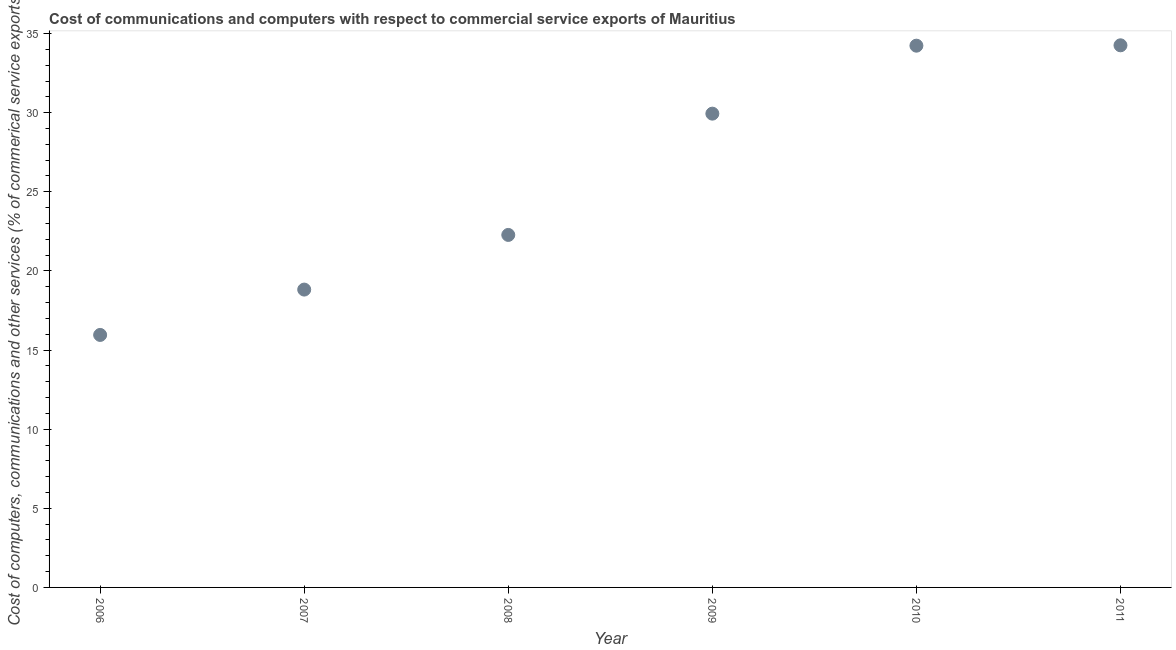What is the  computer and other services in 2011?
Offer a very short reply. 34.26. Across all years, what is the maximum  computer and other services?
Provide a short and direct response. 34.26. Across all years, what is the minimum  computer and other services?
Give a very brief answer. 15.96. In which year was the  computer and other services minimum?
Ensure brevity in your answer.  2006. What is the sum of the  computer and other services?
Your answer should be very brief. 155.49. What is the difference between the  computer and other services in 2008 and 2010?
Your answer should be very brief. -11.96. What is the average  computer and other services per year?
Your response must be concise. 25.91. What is the median  computer and other services?
Provide a short and direct response. 26.11. In how many years, is the cost of communications greater than 28 %?
Make the answer very short. 3. Do a majority of the years between 2009 and 2010 (inclusive) have  computer and other services greater than 10 %?
Your answer should be compact. Yes. What is the ratio of the  computer and other services in 2008 to that in 2010?
Provide a succinct answer. 0.65. What is the difference between the highest and the second highest  computer and other services?
Provide a short and direct response. 0.02. What is the difference between the highest and the lowest cost of communications?
Offer a terse response. 18.3. What is the difference between two consecutive major ticks on the Y-axis?
Give a very brief answer. 5. Are the values on the major ticks of Y-axis written in scientific E-notation?
Keep it short and to the point. No. Does the graph contain grids?
Your answer should be very brief. No. What is the title of the graph?
Make the answer very short. Cost of communications and computers with respect to commercial service exports of Mauritius. What is the label or title of the X-axis?
Provide a succinct answer. Year. What is the label or title of the Y-axis?
Ensure brevity in your answer.  Cost of computers, communications and other services (% of commerical service exports). What is the Cost of computers, communications and other services (% of commerical service exports) in 2006?
Offer a very short reply. 15.96. What is the Cost of computers, communications and other services (% of commerical service exports) in 2007?
Your response must be concise. 18.82. What is the Cost of computers, communications and other services (% of commerical service exports) in 2008?
Ensure brevity in your answer.  22.28. What is the Cost of computers, communications and other services (% of commerical service exports) in 2009?
Give a very brief answer. 29.94. What is the Cost of computers, communications and other services (% of commerical service exports) in 2010?
Provide a short and direct response. 34.24. What is the Cost of computers, communications and other services (% of commerical service exports) in 2011?
Provide a succinct answer. 34.26. What is the difference between the Cost of computers, communications and other services (% of commerical service exports) in 2006 and 2007?
Keep it short and to the point. -2.87. What is the difference between the Cost of computers, communications and other services (% of commerical service exports) in 2006 and 2008?
Your answer should be compact. -6.32. What is the difference between the Cost of computers, communications and other services (% of commerical service exports) in 2006 and 2009?
Offer a terse response. -13.98. What is the difference between the Cost of computers, communications and other services (% of commerical service exports) in 2006 and 2010?
Give a very brief answer. -18.28. What is the difference between the Cost of computers, communications and other services (% of commerical service exports) in 2006 and 2011?
Offer a very short reply. -18.3. What is the difference between the Cost of computers, communications and other services (% of commerical service exports) in 2007 and 2008?
Offer a terse response. -3.45. What is the difference between the Cost of computers, communications and other services (% of commerical service exports) in 2007 and 2009?
Your answer should be compact. -11.12. What is the difference between the Cost of computers, communications and other services (% of commerical service exports) in 2007 and 2010?
Make the answer very short. -15.41. What is the difference between the Cost of computers, communications and other services (% of commerical service exports) in 2007 and 2011?
Keep it short and to the point. -15.44. What is the difference between the Cost of computers, communications and other services (% of commerical service exports) in 2008 and 2009?
Your answer should be compact. -7.66. What is the difference between the Cost of computers, communications and other services (% of commerical service exports) in 2008 and 2010?
Your answer should be compact. -11.96. What is the difference between the Cost of computers, communications and other services (% of commerical service exports) in 2008 and 2011?
Provide a short and direct response. -11.98. What is the difference between the Cost of computers, communications and other services (% of commerical service exports) in 2009 and 2010?
Provide a succinct answer. -4.3. What is the difference between the Cost of computers, communications and other services (% of commerical service exports) in 2009 and 2011?
Give a very brief answer. -4.32. What is the difference between the Cost of computers, communications and other services (% of commerical service exports) in 2010 and 2011?
Your answer should be very brief. -0.02. What is the ratio of the Cost of computers, communications and other services (% of commerical service exports) in 2006 to that in 2007?
Provide a succinct answer. 0.85. What is the ratio of the Cost of computers, communications and other services (% of commerical service exports) in 2006 to that in 2008?
Offer a terse response. 0.72. What is the ratio of the Cost of computers, communications and other services (% of commerical service exports) in 2006 to that in 2009?
Give a very brief answer. 0.53. What is the ratio of the Cost of computers, communications and other services (% of commerical service exports) in 2006 to that in 2010?
Give a very brief answer. 0.47. What is the ratio of the Cost of computers, communications and other services (% of commerical service exports) in 2006 to that in 2011?
Your answer should be very brief. 0.47. What is the ratio of the Cost of computers, communications and other services (% of commerical service exports) in 2007 to that in 2008?
Your answer should be compact. 0.84. What is the ratio of the Cost of computers, communications and other services (% of commerical service exports) in 2007 to that in 2009?
Keep it short and to the point. 0.63. What is the ratio of the Cost of computers, communications and other services (% of commerical service exports) in 2007 to that in 2010?
Offer a terse response. 0.55. What is the ratio of the Cost of computers, communications and other services (% of commerical service exports) in 2007 to that in 2011?
Your answer should be compact. 0.55. What is the ratio of the Cost of computers, communications and other services (% of commerical service exports) in 2008 to that in 2009?
Provide a succinct answer. 0.74. What is the ratio of the Cost of computers, communications and other services (% of commerical service exports) in 2008 to that in 2010?
Offer a terse response. 0.65. What is the ratio of the Cost of computers, communications and other services (% of commerical service exports) in 2008 to that in 2011?
Your response must be concise. 0.65. What is the ratio of the Cost of computers, communications and other services (% of commerical service exports) in 2009 to that in 2010?
Provide a short and direct response. 0.88. What is the ratio of the Cost of computers, communications and other services (% of commerical service exports) in 2009 to that in 2011?
Offer a terse response. 0.87. What is the ratio of the Cost of computers, communications and other services (% of commerical service exports) in 2010 to that in 2011?
Your response must be concise. 1. 